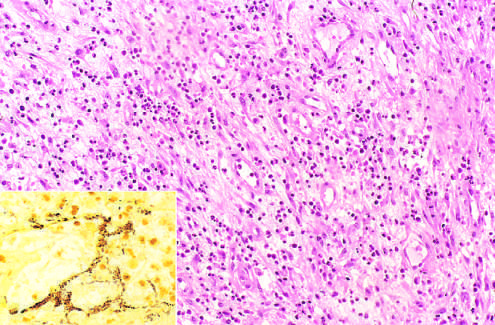re numerous islands of extramedullary hematopoiesis those of acute inflammation and capillary proliferation?
Answer the question using a single word or phrase. No 